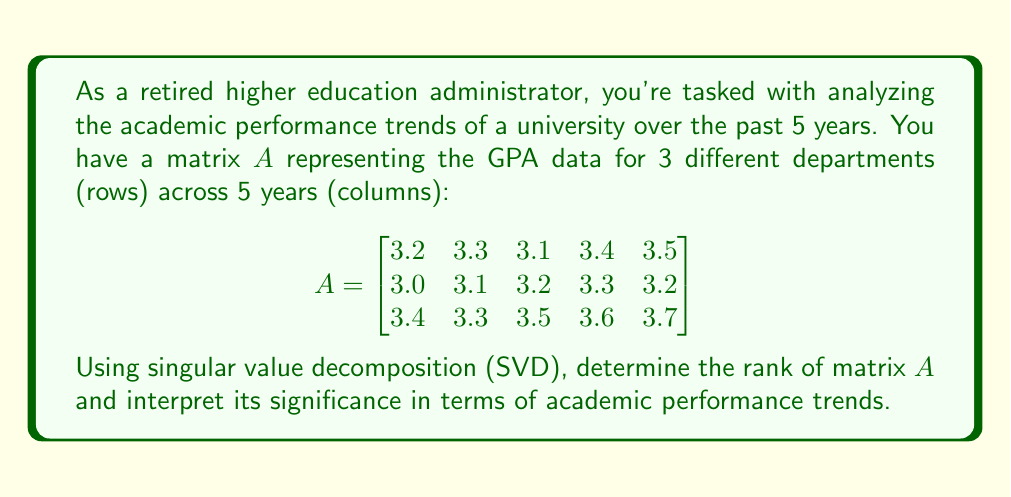Teach me how to tackle this problem. To solve this problem, we'll follow these steps:

1) Recall that SVD decomposes a matrix $A$ into $U\Sigma V^T$, where $\Sigma$ contains the singular values on its diagonal.

2) The rank of $A$ is equal to the number of non-zero singular values.

3) We can use a computational tool to perform SVD on matrix $A$. The singular values are:

   $\sigma_1 \approx 8.2831$
   $\sigma_2 \approx 0.2722$
   $\sigma_3 \approx 0.0447$

4) All three singular values are non-zero, so the rank of $A$ is 3.

5) Interpretation:
   - The rank being 3 (full rank for a 3x5 matrix) indicates that all three rows (departments) contain independent information.
   - This means that each department has a unique performance trend that can't be perfectly reconstructed from the other two.
   - However, the significant drop in magnitude from $\sigma_1$ to $\sigma_2$ and $\sigma_3$ suggests that most of the variation in the data can be captured by a single trend.
   - This dominant trend (represented by the first singular vector) likely represents an overall university-wide performance trend.
   - The smaller $\sigma_2$ and $\sigma_3$ represent department-specific deviations from this main trend.

6) In terms of academic performance, this suggests that while each department has some unique characteristics, there's a strong common trend across all departments. This could be due to university-wide factors affecting all departments similarly (e.g., changes in admission standards, university-wide academic policies, etc.).
Answer: Rank of $A$ is 3; indicates unique trends per department with a strong common university-wide trend. 